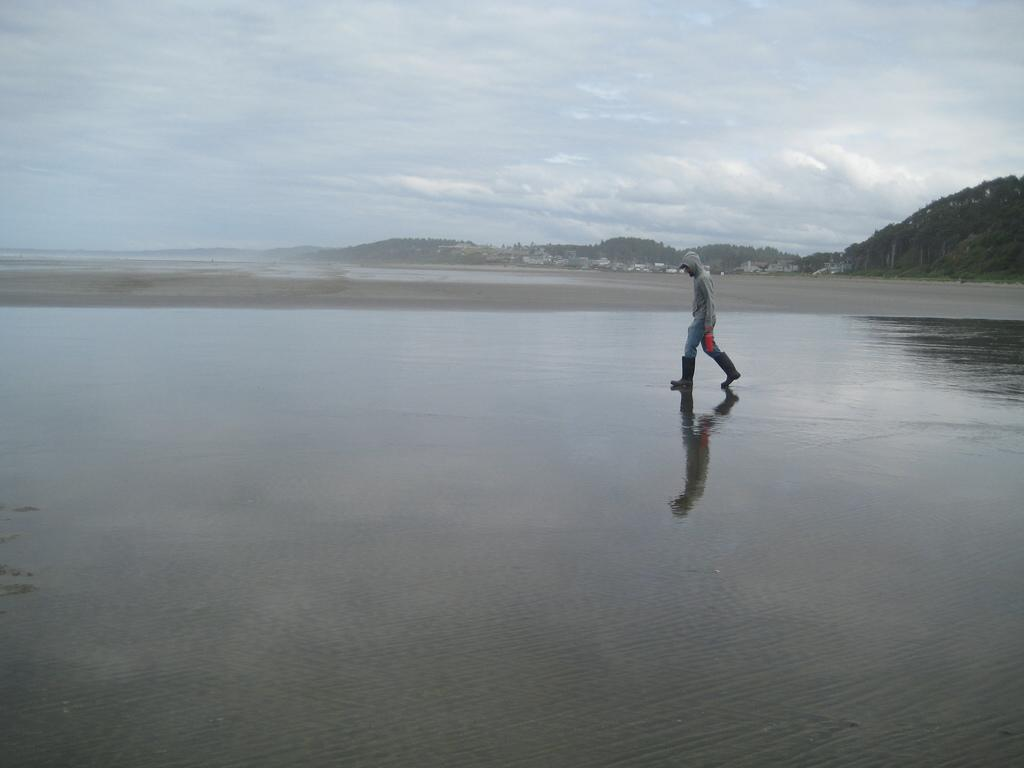What is the main subject of the image? There is a person standing on a seashore in the image. What can be seen in the background of the image? There is a group of buildings, mountains, trees, and a cloudy sky visible in the background. What scientific theory is being discussed by the person in the image? There is no indication in the image that the person is discussing any scientific theory. 